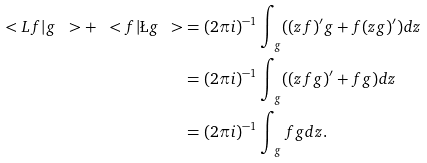<formula> <loc_0><loc_0><loc_500><loc_500>\ < L f | g \ > + \ < f | \L g \ > & = ( 2 \pi i ) ^ { - 1 } \int _ { \ g } ( ( z f ) ^ { \prime } g + f ( z g ) ^ { \prime } ) d z \\ & = ( 2 \pi i ) ^ { - 1 } \int _ { \ g } ( ( z f g ) ^ { \prime } + f g ) d z \\ & = ( 2 \pi i ) ^ { - 1 } \int _ { \ g } f g d z .</formula> 